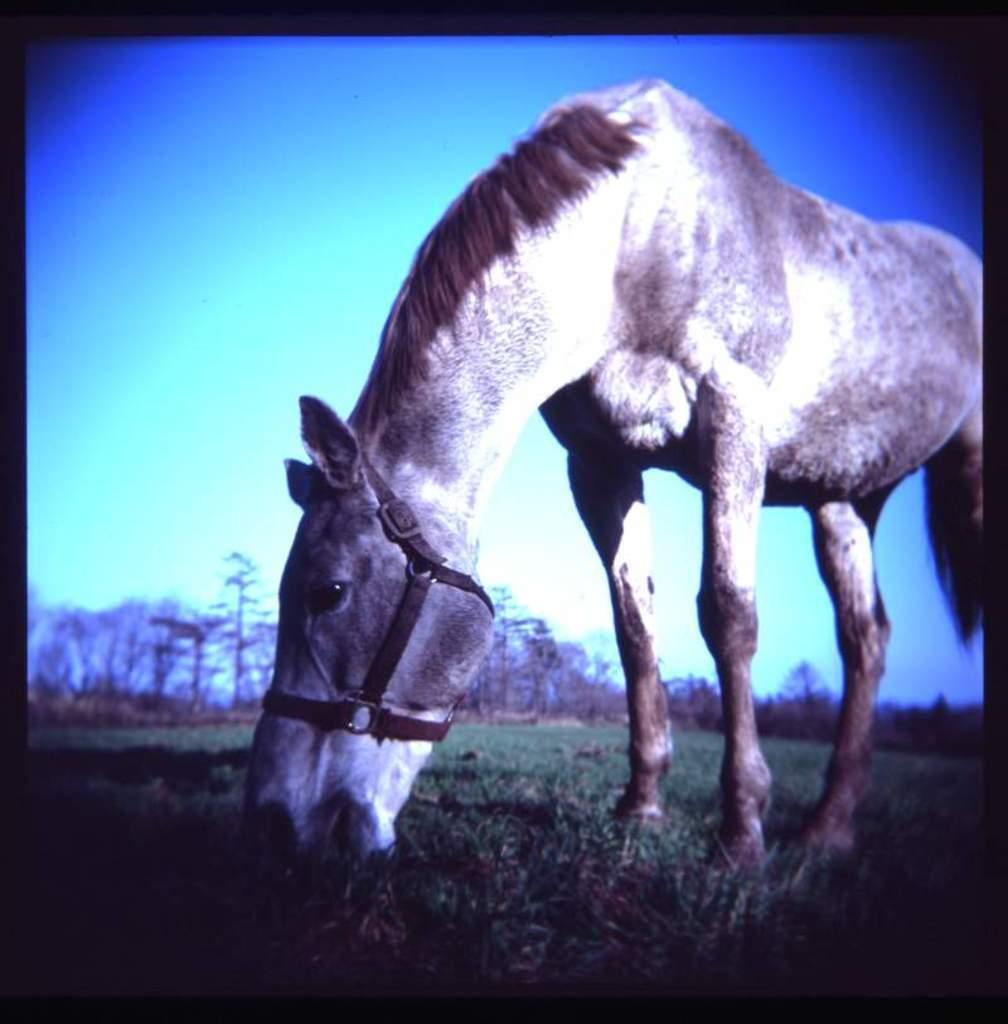Can you describe this image briefly? There is a horse eating the grass on the ground. In the background there are trees and sky. There is a black border for the image. 